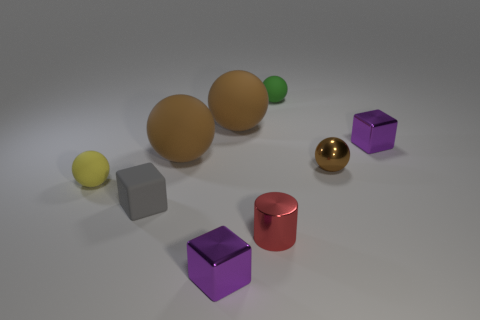What number of objects are small purple shiny blocks that are on the right side of the red shiny cylinder or small brown things?
Ensure brevity in your answer.  2. Are the red cylinder and the tiny purple cube behind the small rubber block made of the same material?
Ensure brevity in your answer.  Yes. There is a brown matte object left of the metallic cube on the left side of the small metal sphere; what shape is it?
Offer a very short reply. Sphere. What is the shape of the tiny red metallic thing?
Make the answer very short. Cylinder. There is a brown matte sphere behind the tiny purple metallic block that is behind the tiny brown shiny ball; what is its size?
Give a very brief answer. Large. Are there an equal number of tiny shiny cubes behind the shiny cylinder and big rubber spheres that are to the left of the yellow thing?
Offer a terse response. No. What material is the ball that is right of the red object and in front of the green rubber object?
Make the answer very short. Metal. Do the gray cube and the brown thing to the right of the green rubber sphere have the same size?
Offer a terse response. Yes. What number of other things are there of the same color as the shiny sphere?
Offer a very short reply. 2. Are there more yellow rubber balls that are on the left side of the small cylinder than small yellow metal blocks?
Your answer should be very brief. Yes. 